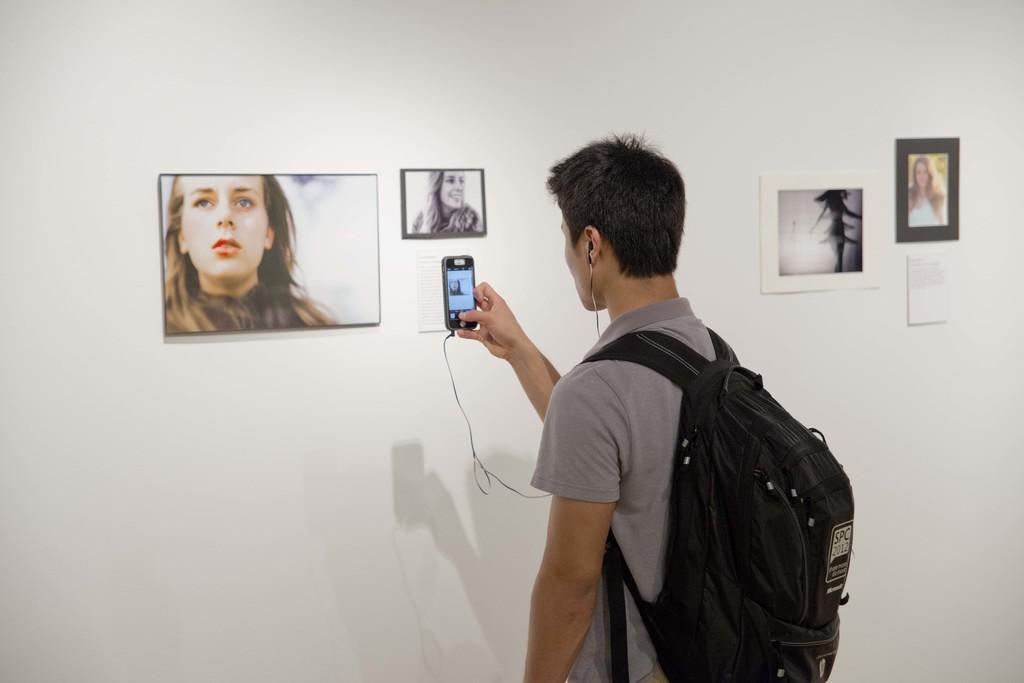Could you give a brief overview of what you see in this image? In this image there is a person carrying a backpack putting a headphones and taking a photo of the painting which is on the wall 